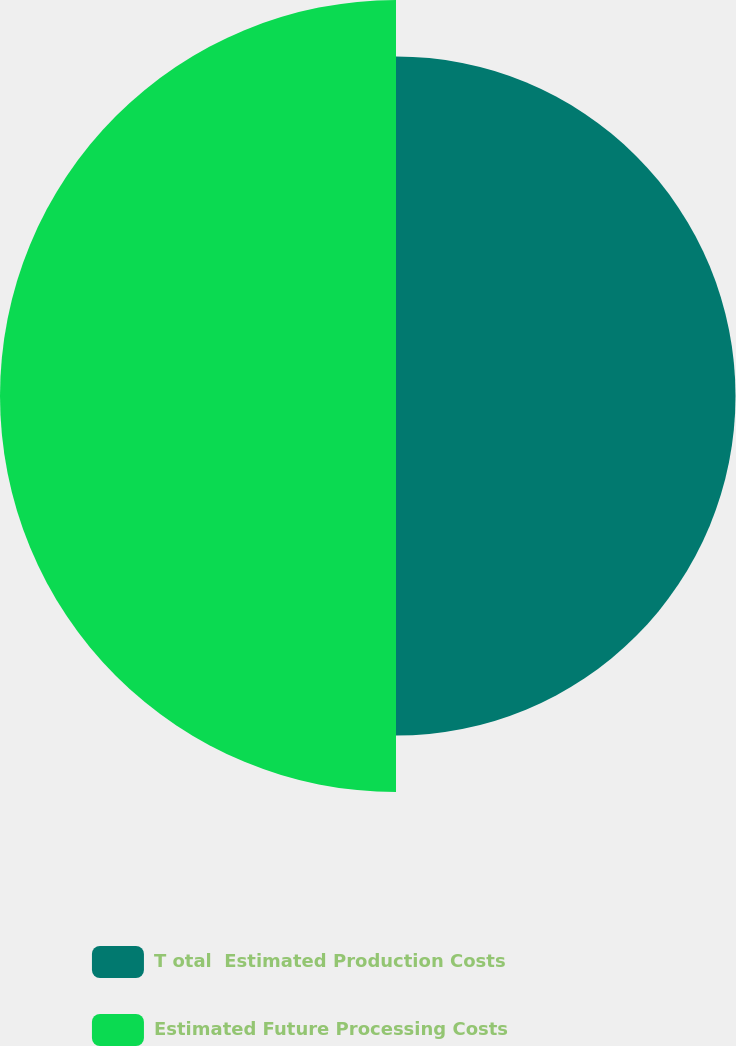<chart> <loc_0><loc_0><loc_500><loc_500><pie_chart><fcel>T otal  Estimated Production Costs<fcel>Estimated Future Processing Costs<nl><fcel>46.16%<fcel>53.84%<nl></chart> 